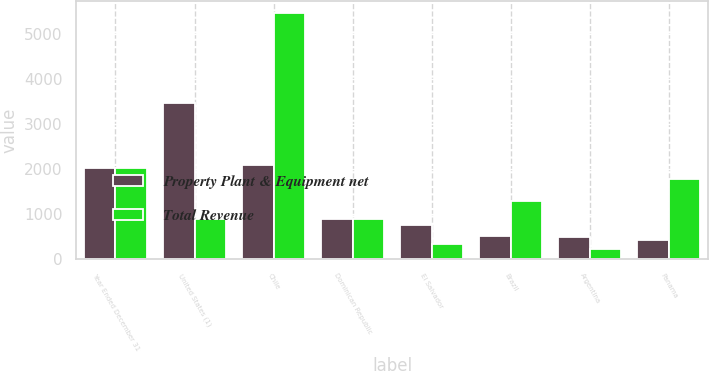<chart> <loc_0><loc_0><loc_500><loc_500><stacked_bar_chart><ecel><fcel>Year Ended December 31<fcel>United States (1)<fcel>Chile<fcel>Dominican Republic<fcel>El Salvador<fcel>Brazil<fcel>Argentina<fcel>Panama<nl><fcel>Property Plant & Equipment net<fcel>2018<fcel>3462<fcel>2087<fcel>884<fcel>768<fcel>527<fcel>487<fcel>438<nl><fcel>Total Revenue<fcel>2018<fcel>903<fcel>5453<fcel>903<fcel>334<fcel>1287<fcel>234<fcel>1777<nl></chart> 